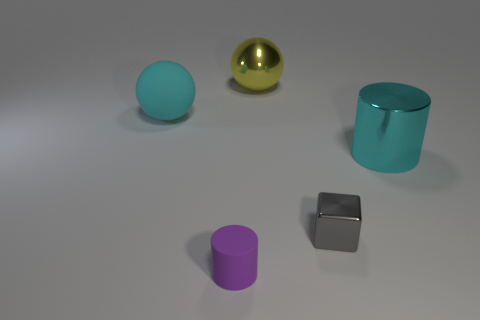What number of tiny objects are cyan spheres or purple cylinders?
Give a very brief answer. 1. There is a gray cube; what number of tiny metal cubes are in front of it?
Your answer should be compact. 0. Is the number of purple cylinders that are on the left side of the tiny metal thing greater than the number of large gray rubber objects?
Make the answer very short. Yes. There is a cyan thing that is the same material as the small cube; what shape is it?
Provide a short and direct response. Cylinder. What color is the big metallic object that is in front of the cyan thing to the left of the big metallic cylinder?
Your answer should be very brief. Cyan. Does the gray metallic thing have the same shape as the big rubber object?
Offer a very short reply. No. There is a yellow object that is the same shape as the cyan rubber object; what material is it?
Your answer should be compact. Metal. Is there a cylinder that is in front of the big cyan object that is on the right side of the rubber object that is behind the cyan cylinder?
Make the answer very short. Yes. Is the shape of the big cyan rubber thing the same as the big shiny thing that is to the left of the cube?
Offer a terse response. Yes. Are there any other things of the same color as the tiny rubber object?
Your response must be concise. No. 